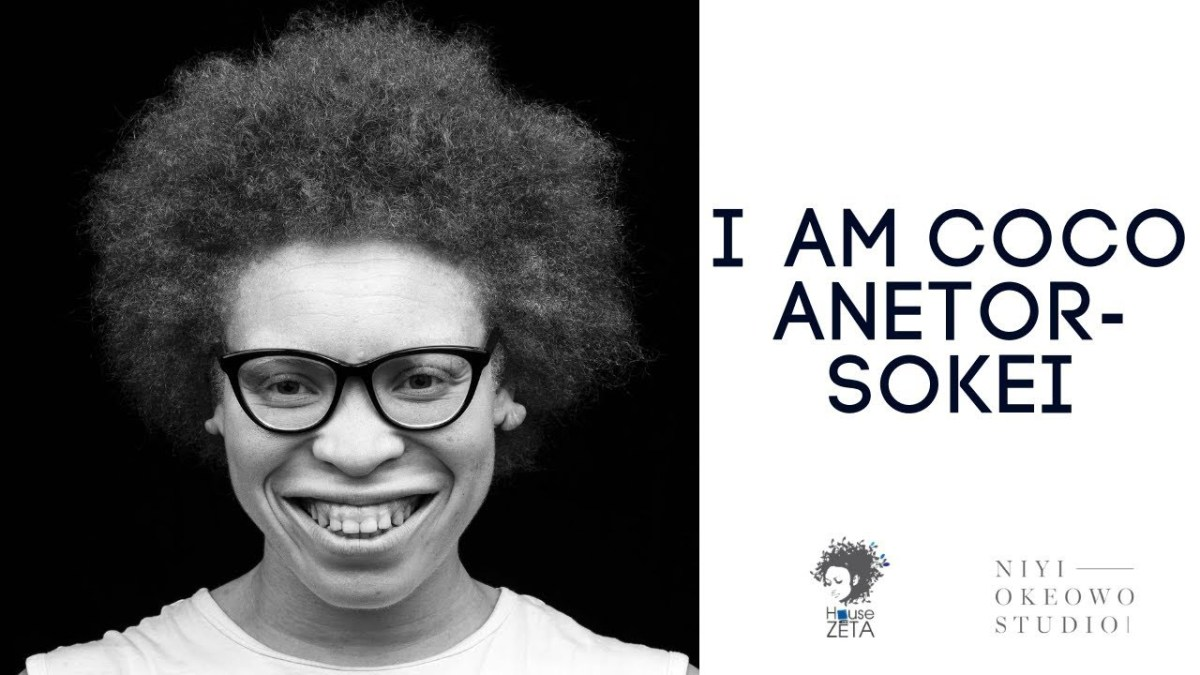How does the design of the logo reflect the personal or artistic identity of Coco Anetor-Sokei? The logo's design features a stylized silhouette that mirrors Coco Anetor-Sokei's distinctive hairstyle, encapsulating a part of her visual identity. This inclusion likely symbolizes her unique approach to art or her personal style, suggesting that the studio values originality and individuality, which are hallmark traits often celebrated in creative industries. 